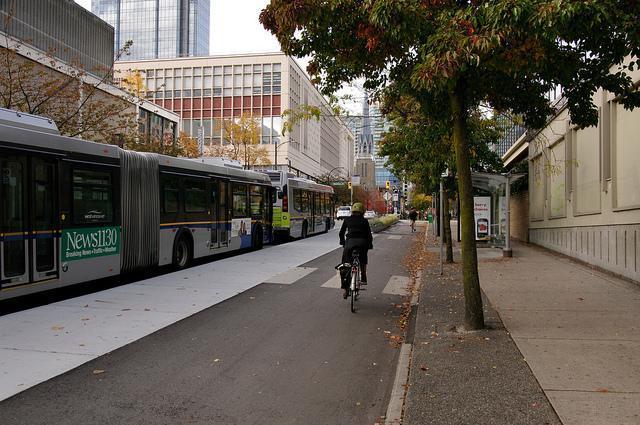How many busses can be seen?
Give a very brief answer. 2. How many buses can be seen?
Give a very brief answer. 2. How many forks are at each place setting?
Give a very brief answer. 0. 